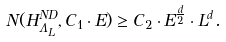Convert formula to latex. <formula><loc_0><loc_0><loc_500><loc_500>N ( H ^ { N D } _ { \Lambda _ { L } } , C _ { 1 } \cdot E ) \geq C _ { 2 } \cdot E ^ { \frac { d } { 2 } } \cdot L ^ { d } .</formula> 